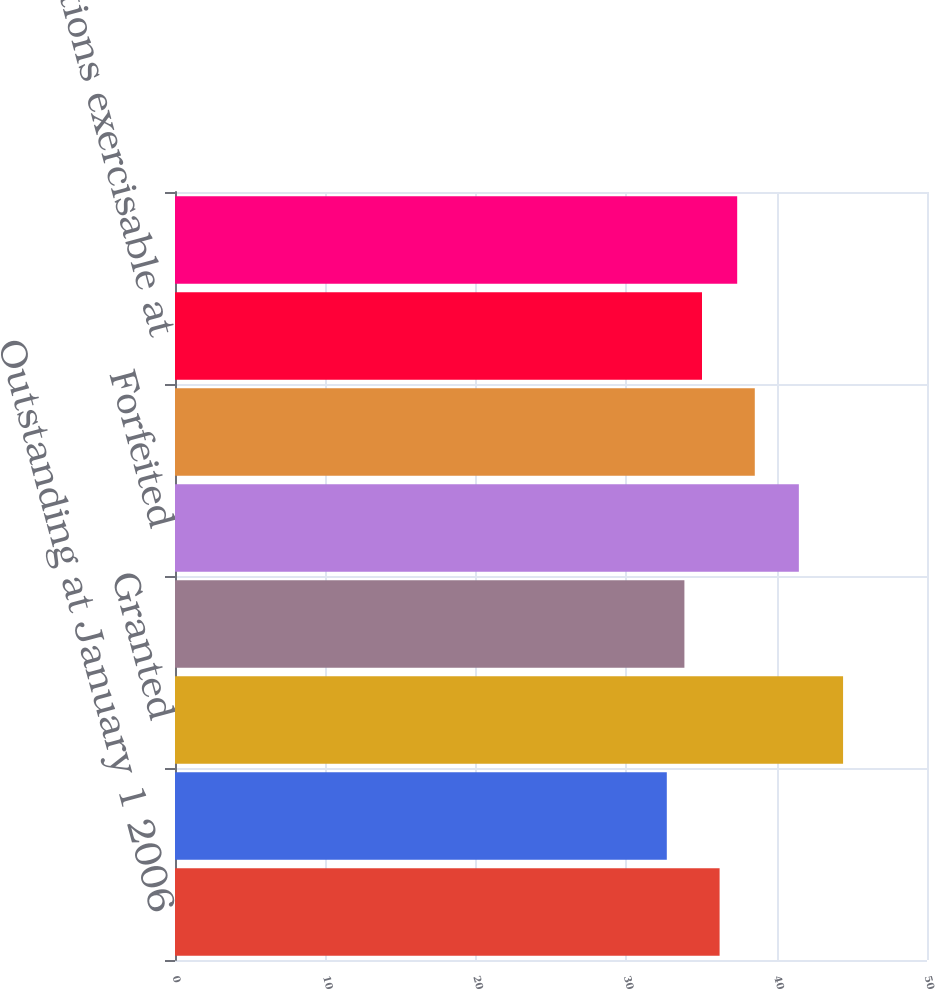<chart> <loc_0><loc_0><loc_500><loc_500><bar_chart><fcel>Outstanding at January 1 2006<fcel>Options assumed through<fcel>Granted<fcel>Exercised<fcel>Forfeited<fcel>Outstanding at December 31<fcel>Options exercisable at<fcel>Options vested and expected to<nl><fcel>36.21<fcel>32.7<fcel>44.42<fcel>33.87<fcel>41.48<fcel>38.55<fcel>35.04<fcel>37.38<nl></chart> 